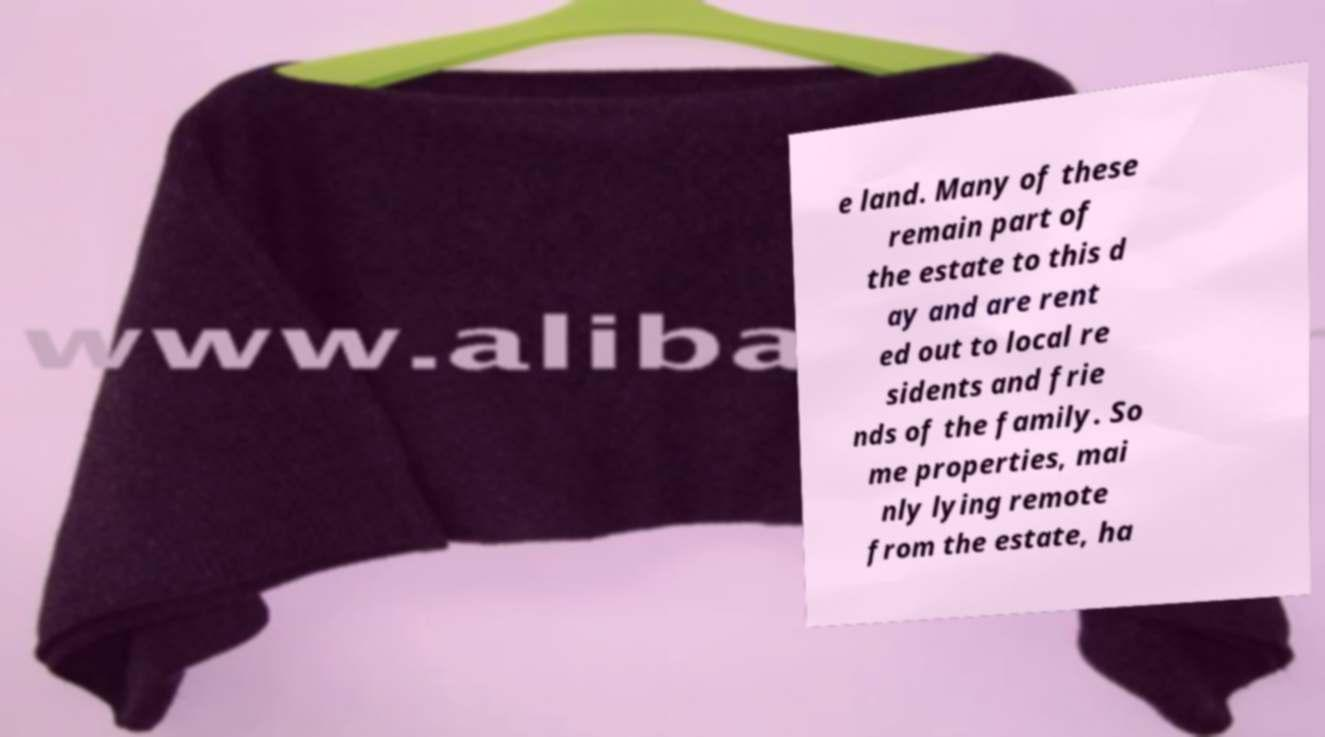There's text embedded in this image that I need extracted. Can you transcribe it verbatim? e land. Many of these remain part of the estate to this d ay and are rent ed out to local re sidents and frie nds of the family. So me properties, mai nly lying remote from the estate, ha 